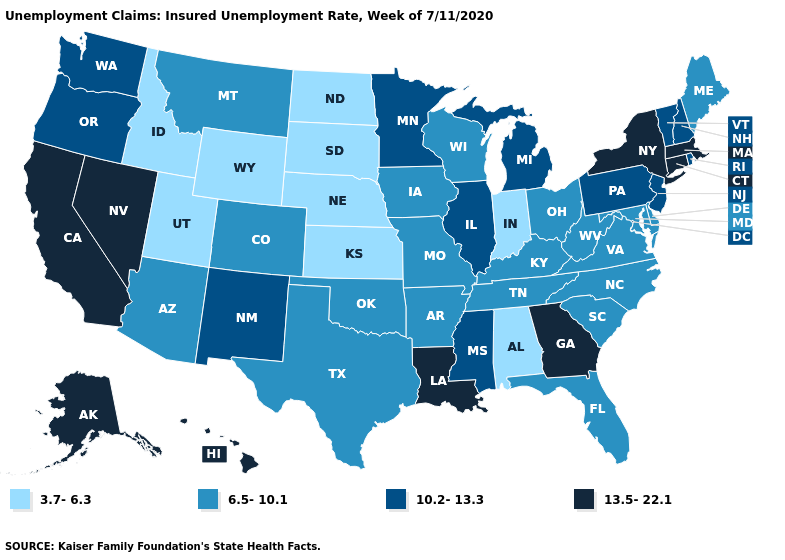What is the value of Kansas?
Be succinct. 3.7-6.3. What is the value of California?
Answer briefly. 13.5-22.1. Name the states that have a value in the range 3.7-6.3?
Write a very short answer. Alabama, Idaho, Indiana, Kansas, Nebraska, North Dakota, South Dakota, Utah, Wyoming. What is the highest value in states that border Texas?
Give a very brief answer. 13.5-22.1. What is the value of South Carolina?
Keep it brief. 6.5-10.1. Does West Virginia have the same value as Vermont?
Keep it brief. No. What is the value of Nevada?
Be succinct. 13.5-22.1. What is the lowest value in the MidWest?
Quick response, please. 3.7-6.3. What is the highest value in the USA?
Short answer required. 13.5-22.1. Name the states that have a value in the range 3.7-6.3?
Quick response, please. Alabama, Idaho, Indiana, Kansas, Nebraska, North Dakota, South Dakota, Utah, Wyoming. Among the states that border Kentucky , does Illinois have the highest value?
Answer briefly. Yes. Which states hav the highest value in the MidWest?
Keep it brief. Illinois, Michigan, Minnesota. Does New Mexico have the highest value in the USA?
Give a very brief answer. No. Among the states that border New York , does Pennsylvania have the highest value?
Give a very brief answer. No. Does Indiana have the same value as California?
Short answer required. No. 